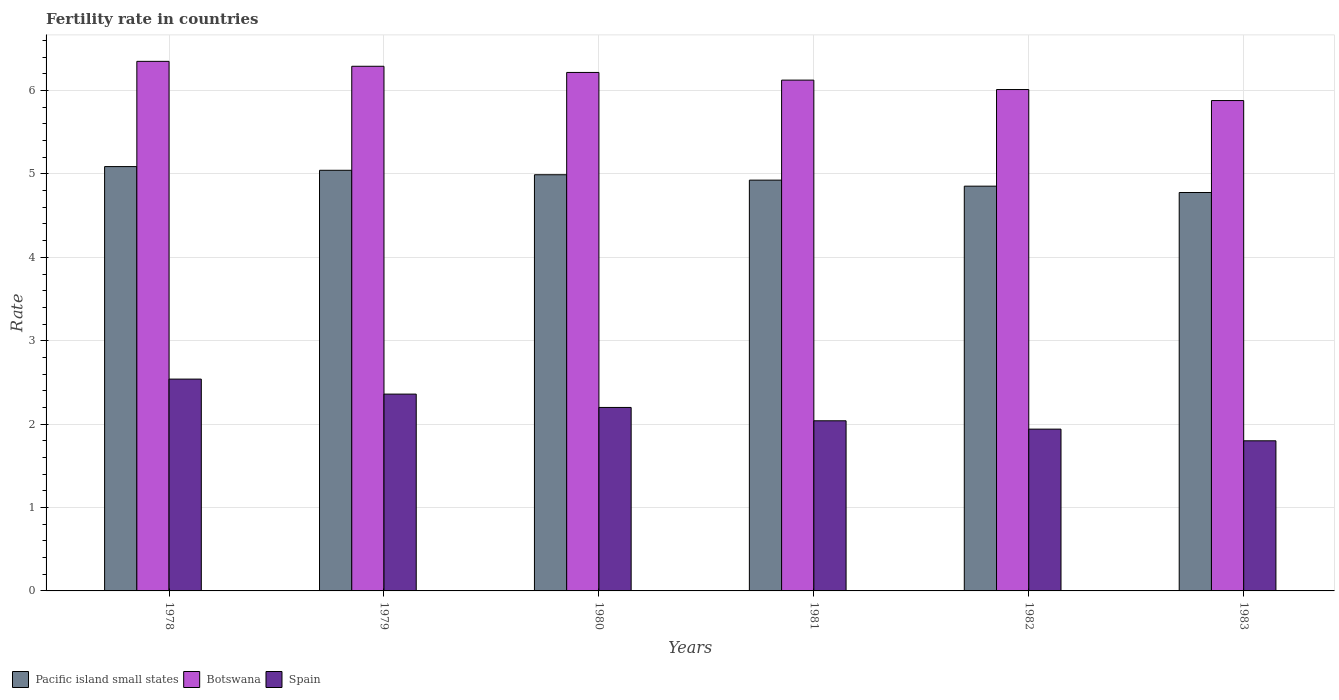How many different coloured bars are there?
Keep it short and to the point. 3. How many groups of bars are there?
Keep it short and to the point. 6. Are the number of bars on each tick of the X-axis equal?
Ensure brevity in your answer.  Yes. How many bars are there on the 1st tick from the left?
Your response must be concise. 3. In how many cases, is the number of bars for a given year not equal to the number of legend labels?
Offer a terse response. 0. What is the fertility rate in Pacific island small states in 1978?
Offer a very short reply. 5.09. Across all years, what is the maximum fertility rate in Spain?
Provide a succinct answer. 2.54. Across all years, what is the minimum fertility rate in Botswana?
Give a very brief answer. 5.88. In which year was the fertility rate in Pacific island small states maximum?
Offer a very short reply. 1978. In which year was the fertility rate in Pacific island small states minimum?
Your answer should be very brief. 1983. What is the total fertility rate in Spain in the graph?
Your answer should be compact. 12.88. What is the difference between the fertility rate in Pacific island small states in 1978 and that in 1983?
Provide a short and direct response. 0.31. What is the difference between the fertility rate in Spain in 1980 and the fertility rate in Pacific island small states in 1979?
Make the answer very short. -2.84. What is the average fertility rate in Spain per year?
Offer a terse response. 2.15. In the year 1980, what is the difference between the fertility rate in Spain and fertility rate in Pacific island small states?
Keep it short and to the point. -2.79. In how many years, is the fertility rate in Pacific island small states greater than 1?
Provide a short and direct response. 6. What is the ratio of the fertility rate in Pacific island small states in 1982 to that in 1983?
Provide a succinct answer. 1.02. Is the fertility rate in Botswana in 1980 less than that in 1981?
Make the answer very short. No. Is the difference between the fertility rate in Spain in 1981 and 1983 greater than the difference between the fertility rate in Pacific island small states in 1981 and 1983?
Provide a short and direct response. Yes. What is the difference between the highest and the second highest fertility rate in Pacific island small states?
Offer a terse response. 0.04. What is the difference between the highest and the lowest fertility rate in Botswana?
Provide a short and direct response. 0.47. What does the 3rd bar from the left in 1981 represents?
Provide a short and direct response. Spain. What does the 2nd bar from the right in 1982 represents?
Provide a succinct answer. Botswana. Are all the bars in the graph horizontal?
Provide a short and direct response. No. Are the values on the major ticks of Y-axis written in scientific E-notation?
Offer a terse response. No. Does the graph contain grids?
Your response must be concise. Yes. How many legend labels are there?
Provide a succinct answer. 3. How are the legend labels stacked?
Give a very brief answer. Horizontal. What is the title of the graph?
Provide a succinct answer. Fertility rate in countries. Does "Middle East & North Africa (all income levels)" appear as one of the legend labels in the graph?
Offer a terse response. No. What is the label or title of the Y-axis?
Ensure brevity in your answer.  Rate. What is the Rate in Pacific island small states in 1978?
Your answer should be very brief. 5.09. What is the Rate of Botswana in 1978?
Your answer should be very brief. 6.35. What is the Rate of Spain in 1978?
Offer a terse response. 2.54. What is the Rate in Pacific island small states in 1979?
Make the answer very short. 5.04. What is the Rate of Botswana in 1979?
Keep it short and to the point. 6.29. What is the Rate in Spain in 1979?
Your response must be concise. 2.36. What is the Rate in Pacific island small states in 1980?
Make the answer very short. 4.99. What is the Rate in Botswana in 1980?
Make the answer very short. 6.22. What is the Rate of Spain in 1980?
Your answer should be compact. 2.2. What is the Rate in Pacific island small states in 1981?
Make the answer very short. 4.93. What is the Rate of Botswana in 1981?
Ensure brevity in your answer.  6.12. What is the Rate in Spain in 1981?
Your answer should be compact. 2.04. What is the Rate in Pacific island small states in 1982?
Offer a very short reply. 4.85. What is the Rate in Botswana in 1982?
Provide a succinct answer. 6.01. What is the Rate in Spain in 1982?
Keep it short and to the point. 1.94. What is the Rate in Pacific island small states in 1983?
Your response must be concise. 4.78. What is the Rate in Botswana in 1983?
Provide a succinct answer. 5.88. Across all years, what is the maximum Rate of Pacific island small states?
Make the answer very short. 5.09. Across all years, what is the maximum Rate in Botswana?
Your answer should be compact. 6.35. Across all years, what is the maximum Rate of Spain?
Make the answer very short. 2.54. Across all years, what is the minimum Rate in Pacific island small states?
Your answer should be very brief. 4.78. Across all years, what is the minimum Rate of Botswana?
Keep it short and to the point. 5.88. What is the total Rate of Pacific island small states in the graph?
Keep it short and to the point. 29.68. What is the total Rate of Botswana in the graph?
Ensure brevity in your answer.  36.88. What is the total Rate in Spain in the graph?
Offer a very short reply. 12.88. What is the difference between the Rate of Pacific island small states in 1978 and that in 1979?
Provide a succinct answer. 0.04. What is the difference between the Rate in Botswana in 1978 and that in 1979?
Give a very brief answer. 0.06. What is the difference between the Rate of Spain in 1978 and that in 1979?
Offer a terse response. 0.18. What is the difference between the Rate of Pacific island small states in 1978 and that in 1980?
Your response must be concise. 0.1. What is the difference between the Rate of Botswana in 1978 and that in 1980?
Your answer should be very brief. 0.13. What is the difference between the Rate in Spain in 1978 and that in 1980?
Ensure brevity in your answer.  0.34. What is the difference between the Rate in Pacific island small states in 1978 and that in 1981?
Keep it short and to the point. 0.16. What is the difference between the Rate of Botswana in 1978 and that in 1981?
Provide a short and direct response. 0.23. What is the difference between the Rate in Spain in 1978 and that in 1981?
Keep it short and to the point. 0.5. What is the difference between the Rate in Pacific island small states in 1978 and that in 1982?
Make the answer very short. 0.23. What is the difference between the Rate in Botswana in 1978 and that in 1982?
Your answer should be very brief. 0.34. What is the difference between the Rate in Pacific island small states in 1978 and that in 1983?
Offer a very short reply. 0.31. What is the difference between the Rate of Botswana in 1978 and that in 1983?
Offer a terse response. 0.47. What is the difference between the Rate in Spain in 1978 and that in 1983?
Offer a terse response. 0.74. What is the difference between the Rate of Pacific island small states in 1979 and that in 1980?
Provide a succinct answer. 0.05. What is the difference between the Rate of Botswana in 1979 and that in 1980?
Keep it short and to the point. 0.07. What is the difference between the Rate in Spain in 1979 and that in 1980?
Your answer should be very brief. 0.16. What is the difference between the Rate in Pacific island small states in 1979 and that in 1981?
Your response must be concise. 0.12. What is the difference between the Rate in Botswana in 1979 and that in 1981?
Offer a terse response. 0.17. What is the difference between the Rate of Spain in 1979 and that in 1981?
Offer a terse response. 0.32. What is the difference between the Rate of Pacific island small states in 1979 and that in 1982?
Make the answer very short. 0.19. What is the difference between the Rate in Botswana in 1979 and that in 1982?
Provide a short and direct response. 0.28. What is the difference between the Rate in Spain in 1979 and that in 1982?
Provide a short and direct response. 0.42. What is the difference between the Rate of Pacific island small states in 1979 and that in 1983?
Give a very brief answer. 0.27. What is the difference between the Rate in Botswana in 1979 and that in 1983?
Offer a very short reply. 0.41. What is the difference between the Rate of Spain in 1979 and that in 1983?
Ensure brevity in your answer.  0.56. What is the difference between the Rate in Pacific island small states in 1980 and that in 1981?
Make the answer very short. 0.06. What is the difference between the Rate in Botswana in 1980 and that in 1981?
Provide a short and direct response. 0.09. What is the difference between the Rate of Spain in 1980 and that in 1981?
Keep it short and to the point. 0.16. What is the difference between the Rate in Pacific island small states in 1980 and that in 1982?
Ensure brevity in your answer.  0.14. What is the difference between the Rate in Botswana in 1980 and that in 1982?
Make the answer very short. 0.2. What is the difference between the Rate in Spain in 1980 and that in 1982?
Offer a very short reply. 0.26. What is the difference between the Rate in Pacific island small states in 1980 and that in 1983?
Ensure brevity in your answer.  0.21. What is the difference between the Rate of Botswana in 1980 and that in 1983?
Keep it short and to the point. 0.34. What is the difference between the Rate in Spain in 1980 and that in 1983?
Provide a short and direct response. 0.4. What is the difference between the Rate in Pacific island small states in 1981 and that in 1982?
Give a very brief answer. 0.07. What is the difference between the Rate of Botswana in 1981 and that in 1982?
Offer a very short reply. 0.11. What is the difference between the Rate in Spain in 1981 and that in 1982?
Offer a very short reply. 0.1. What is the difference between the Rate in Pacific island small states in 1981 and that in 1983?
Offer a terse response. 0.15. What is the difference between the Rate in Botswana in 1981 and that in 1983?
Offer a terse response. 0.24. What is the difference between the Rate of Spain in 1981 and that in 1983?
Keep it short and to the point. 0.24. What is the difference between the Rate of Pacific island small states in 1982 and that in 1983?
Offer a very short reply. 0.08. What is the difference between the Rate in Botswana in 1982 and that in 1983?
Offer a very short reply. 0.13. What is the difference between the Rate of Spain in 1982 and that in 1983?
Keep it short and to the point. 0.14. What is the difference between the Rate in Pacific island small states in 1978 and the Rate in Botswana in 1979?
Give a very brief answer. -1.2. What is the difference between the Rate in Pacific island small states in 1978 and the Rate in Spain in 1979?
Ensure brevity in your answer.  2.73. What is the difference between the Rate of Botswana in 1978 and the Rate of Spain in 1979?
Keep it short and to the point. 3.99. What is the difference between the Rate in Pacific island small states in 1978 and the Rate in Botswana in 1980?
Your answer should be compact. -1.13. What is the difference between the Rate in Pacific island small states in 1978 and the Rate in Spain in 1980?
Offer a very short reply. 2.89. What is the difference between the Rate in Botswana in 1978 and the Rate in Spain in 1980?
Ensure brevity in your answer.  4.15. What is the difference between the Rate in Pacific island small states in 1978 and the Rate in Botswana in 1981?
Your answer should be very brief. -1.04. What is the difference between the Rate in Pacific island small states in 1978 and the Rate in Spain in 1981?
Offer a terse response. 3.05. What is the difference between the Rate in Botswana in 1978 and the Rate in Spain in 1981?
Offer a very short reply. 4.31. What is the difference between the Rate of Pacific island small states in 1978 and the Rate of Botswana in 1982?
Your answer should be compact. -0.92. What is the difference between the Rate of Pacific island small states in 1978 and the Rate of Spain in 1982?
Your response must be concise. 3.15. What is the difference between the Rate of Botswana in 1978 and the Rate of Spain in 1982?
Provide a short and direct response. 4.41. What is the difference between the Rate in Pacific island small states in 1978 and the Rate in Botswana in 1983?
Your answer should be very brief. -0.79. What is the difference between the Rate in Pacific island small states in 1978 and the Rate in Spain in 1983?
Give a very brief answer. 3.29. What is the difference between the Rate of Botswana in 1978 and the Rate of Spain in 1983?
Offer a terse response. 4.55. What is the difference between the Rate in Pacific island small states in 1979 and the Rate in Botswana in 1980?
Your answer should be compact. -1.17. What is the difference between the Rate of Pacific island small states in 1979 and the Rate of Spain in 1980?
Ensure brevity in your answer.  2.84. What is the difference between the Rate in Botswana in 1979 and the Rate in Spain in 1980?
Ensure brevity in your answer.  4.09. What is the difference between the Rate in Pacific island small states in 1979 and the Rate in Botswana in 1981?
Your answer should be compact. -1.08. What is the difference between the Rate in Pacific island small states in 1979 and the Rate in Spain in 1981?
Your answer should be very brief. 3. What is the difference between the Rate in Botswana in 1979 and the Rate in Spain in 1981?
Give a very brief answer. 4.25. What is the difference between the Rate of Pacific island small states in 1979 and the Rate of Botswana in 1982?
Give a very brief answer. -0.97. What is the difference between the Rate in Pacific island small states in 1979 and the Rate in Spain in 1982?
Ensure brevity in your answer.  3.1. What is the difference between the Rate of Botswana in 1979 and the Rate of Spain in 1982?
Provide a succinct answer. 4.35. What is the difference between the Rate of Pacific island small states in 1979 and the Rate of Botswana in 1983?
Offer a terse response. -0.84. What is the difference between the Rate of Pacific island small states in 1979 and the Rate of Spain in 1983?
Offer a terse response. 3.24. What is the difference between the Rate of Botswana in 1979 and the Rate of Spain in 1983?
Offer a terse response. 4.49. What is the difference between the Rate in Pacific island small states in 1980 and the Rate in Botswana in 1981?
Ensure brevity in your answer.  -1.13. What is the difference between the Rate of Pacific island small states in 1980 and the Rate of Spain in 1981?
Your answer should be very brief. 2.95. What is the difference between the Rate of Botswana in 1980 and the Rate of Spain in 1981?
Provide a short and direct response. 4.18. What is the difference between the Rate in Pacific island small states in 1980 and the Rate in Botswana in 1982?
Make the answer very short. -1.02. What is the difference between the Rate in Pacific island small states in 1980 and the Rate in Spain in 1982?
Your response must be concise. 3.05. What is the difference between the Rate in Botswana in 1980 and the Rate in Spain in 1982?
Give a very brief answer. 4.28. What is the difference between the Rate of Pacific island small states in 1980 and the Rate of Botswana in 1983?
Keep it short and to the point. -0.89. What is the difference between the Rate in Pacific island small states in 1980 and the Rate in Spain in 1983?
Offer a very short reply. 3.19. What is the difference between the Rate of Botswana in 1980 and the Rate of Spain in 1983?
Provide a short and direct response. 4.42. What is the difference between the Rate in Pacific island small states in 1981 and the Rate in Botswana in 1982?
Your answer should be very brief. -1.09. What is the difference between the Rate of Pacific island small states in 1981 and the Rate of Spain in 1982?
Ensure brevity in your answer.  2.99. What is the difference between the Rate in Botswana in 1981 and the Rate in Spain in 1982?
Give a very brief answer. 4.18. What is the difference between the Rate of Pacific island small states in 1981 and the Rate of Botswana in 1983?
Your response must be concise. -0.95. What is the difference between the Rate in Pacific island small states in 1981 and the Rate in Spain in 1983?
Make the answer very short. 3.13. What is the difference between the Rate in Botswana in 1981 and the Rate in Spain in 1983?
Keep it short and to the point. 4.33. What is the difference between the Rate in Pacific island small states in 1982 and the Rate in Botswana in 1983?
Your answer should be very brief. -1.03. What is the difference between the Rate of Pacific island small states in 1982 and the Rate of Spain in 1983?
Offer a very short reply. 3.05. What is the difference between the Rate of Botswana in 1982 and the Rate of Spain in 1983?
Your answer should be compact. 4.21. What is the average Rate of Pacific island small states per year?
Your response must be concise. 4.95. What is the average Rate in Botswana per year?
Provide a short and direct response. 6.15. What is the average Rate of Spain per year?
Provide a short and direct response. 2.15. In the year 1978, what is the difference between the Rate in Pacific island small states and Rate in Botswana?
Keep it short and to the point. -1.26. In the year 1978, what is the difference between the Rate in Pacific island small states and Rate in Spain?
Offer a terse response. 2.55. In the year 1978, what is the difference between the Rate in Botswana and Rate in Spain?
Keep it short and to the point. 3.81. In the year 1979, what is the difference between the Rate of Pacific island small states and Rate of Botswana?
Your answer should be very brief. -1.25. In the year 1979, what is the difference between the Rate of Pacific island small states and Rate of Spain?
Give a very brief answer. 2.68. In the year 1979, what is the difference between the Rate of Botswana and Rate of Spain?
Offer a very short reply. 3.93. In the year 1980, what is the difference between the Rate of Pacific island small states and Rate of Botswana?
Your answer should be compact. -1.23. In the year 1980, what is the difference between the Rate in Pacific island small states and Rate in Spain?
Your answer should be compact. 2.79. In the year 1980, what is the difference between the Rate of Botswana and Rate of Spain?
Your answer should be very brief. 4.02. In the year 1981, what is the difference between the Rate of Pacific island small states and Rate of Botswana?
Your response must be concise. -1.2. In the year 1981, what is the difference between the Rate of Pacific island small states and Rate of Spain?
Offer a very short reply. 2.89. In the year 1981, what is the difference between the Rate in Botswana and Rate in Spain?
Your answer should be very brief. 4.08. In the year 1982, what is the difference between the Rate of Pacific island small states and Rate of Botswana?
Ensure brevity in your answer.  -1.16. In the year 1982, what is the difference between the Rate in Pacific island small states and Rate in Spain?
Provide a succinct answer. 2.91. In the year 1982, what is the difference between the Rate in Botswana and Rate in Spain?
Ensure brevity in your answer.  4.07. In the year 1983, what is the difference between the Rate of Pacific island small states and Rate of Botswana?
Offer a very short reply. -1.1. In the year 1983, what is the difference between the Rate in Pacific island small states and Rate in Spain?
Give a very brief answer. 2.98. In the year 1983, what is the difference between the Rate of Botswana and Rate of Spain?
Provide a short and direct response. 4.08. What is the ratio of the Rate of Pacific island small states in 1978 to that in 1979?
Give a very brief answer. 1.01. What is the ratio of the Rate in Botswana in 1978 to that in 1979?
Offer a terse response. 1.01. What is the ratio of the Rate in Spain in 1978 to that in 1979?
Offer a terse response. 1.08. What is the ratio of the Rate in Pacific island small states in 1978 to that in 1980?
Give a very brief answer. 1.02. What is the ratio of the Rate in Botswana in 1978 to that in 1980?
Ensure brevity in your answer.  1.02. What is the ratio of the Rate in Spain in 1978 to that in 1980?
Your answer should be compact. 1.15. What is the ratio of the Rate of Pacific island small states in 1978 to that in 1981?
Ensure brevity in your answer.  1.03. What is the ratio of the Rate in Botswana in 1978 to that in 1981?
Your answer should be compact. 1.04. What is the ratio of the Rate in Spain in 1978 to that in 1981?
Make the answer very short. 1.25. What is the ratio of the Rate in Pacific island small states in 1978 to that in 1982?
Ensure brevity in your answer.  1.05. What is the ratio of the Rate of Botswana in 1978 to that in 1982?
Give a very brief answer. 1.06. What is the ratio of the Rate of Spain in 1978 to that in 1982?
Your answer should be compact. 1.31. What is the ratio of the Rate of Pacific island small states in 1978 to that in 1983?
Provide a succinct answer. 1.07. What is the ratio of the Rate of Botswana in 1978 to that in 1983?
Your answer should be compact. 1.08. What is the ratio of the Rate in Spain in 1978 to that in 1983?
Your response must be concise. 1.41. What is the ratio of the Rate of Pacific island small states in 1979 to that in 1980?
Offer a terse response. 1.01. What is the ratio of the Rate in Botswana in 1979 to that in 1980?
Give a very brief answer. 1.01. What is the ratio of the Rate of Spain in 1979 to that in 1980?
Provide a short and direct response. 1.07. What is the ratio of the Rate of Pacific island small states in 1979 to that in 1981?
Your answer should be very brief. 1.02. What is the ratio of the Rate of Botswana in 1979 to that in 1981?
Provide a short and direct response. 1.03. What is the ratio of the Rate in Spain in 1979 to that in 1981?
Your answer should be compact. 1.16. What is the ratio of the Rate of Pacific island small states in 1979 to that in 1982?
Offer a very short reply. 1.04. What is the ratio of the Rate of Botswana in 1979 to that in 1982?
Provide a succinct answer. 1.05. What is the ratio of the Rate of Spain in 1979 to that in 1982?
Offer a terse response. 1.22. What is the ratio of the Rate in Pacific island small states in 1979 to that in 1983?
Ensure brevity in your answer.  1.06. What is the ratio of the Rate in Botswana in 1979 to that in 1983?
Keep it short and to the point. 1.07. What is the ratio of the Rate of Spain in 1979 to that in 1983?
Offer a terse response. 1.31. What is the ratio of the Rate in Pacific island small states in 1980 to that in 1981?
Give a very brief answer. 1.01. What is the ratio of the Rate of Spain in 1980 to that in 1981?
Your answer should be compact. 1.08. What is the ratio of the Rate of Pacific island small states in 1980 to that in 1982?
Your answer should be very brief. 1.03. What is the ratio of the Rate in Botswana in 1980 to that in 1982?
Your response must be concise. 1.03. What is the ratio of the Rate of Spain in 1980 to that in 1982?
Provide a short and direct response. 1.13. What is the ratio of the Rate in Pacific island small states in 1980 to that in 1983?
Offer a terse response. 1.04. What is the ratio of the Rate of Botswana in 1980 to that in 1983?
Offer a terse response. 1.06. What is the ratio of the Rate of Spain in 1980 to that in 1983?
Your answer should be very brief. 1.22. What is the ratio of the Rate in Pacific island small states in 1981 to that in 1982?
Keep it short and to the point. 1.01. What is the ratio of the Rate of Botswana in 1981 to that in 1982?
Ensure brevity in your answer.  1.02. What is the ratio of the Rate in Spain in 1981 to that in 1982?
Give a very brief answer. 1.05. What is the ratio of the Rate of Pacific island small states in 1981 to that in 1983?
Offer a terse response. 1.03. What is the ratio of the Rate in Botswana in 1981 to that in 1983?
Give a very brief answer. 1.04. What is the ratio of the Rate of Spain in 1981 to that in 1983?
Provide a succinct answer. 1.13. What is the ratio of the Rate of Pacific island small states in 1982 to that in 1983?
Keep it short and to the point. 1.02. What is the ratio of the Rate in Botswana in 1982 to that in 1983?
Keep it short and to the point. 1.02. What is the ratio of the Rate of Spain in 1982 to that in 1983?
Give a very brief answer. 1.08. What is the difference between the highest and the second highest Rate of Pacific island small states?
Your answer should be very brief. 0.04. What is the difference between the highest and the second highest Rate in Botswana?
Offer a very short reply. 0.06. What is the difference between the highest and the second highest Rate in Spain?
Offer a terse response. 0.18. What is the difference between the highest and the lowest Rate of Pacific island small states?
Offer a terse response. 0.31. What is the difference between the highest and the lowest Rate of Botswana?
Offer a very short reply. 0.47. What is the difference between the highest and the lowest Rate in Spain?
Keep it short and to the point. 0.74. 